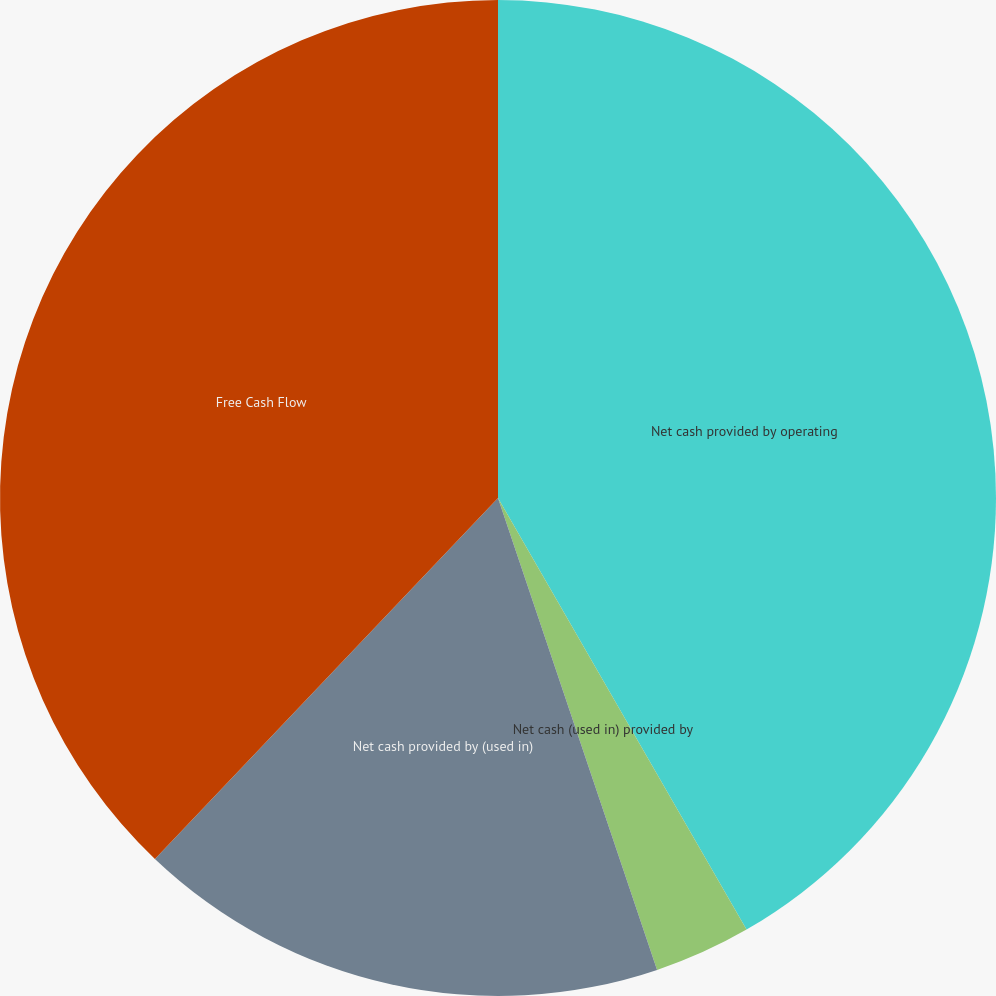<chart> <loc_0><loc_0><loc_500><loc_500><pie_chart><fcel>Net cash provided by operating<fcel>Net cash (used in) provided by<fcel>Net cash provided by (used in)<fcel>Free Cash Flow<nl><fcel>41.68%<fcel>3.14%<fcel>17.27%<fcel>37.9%<nl></chart> 